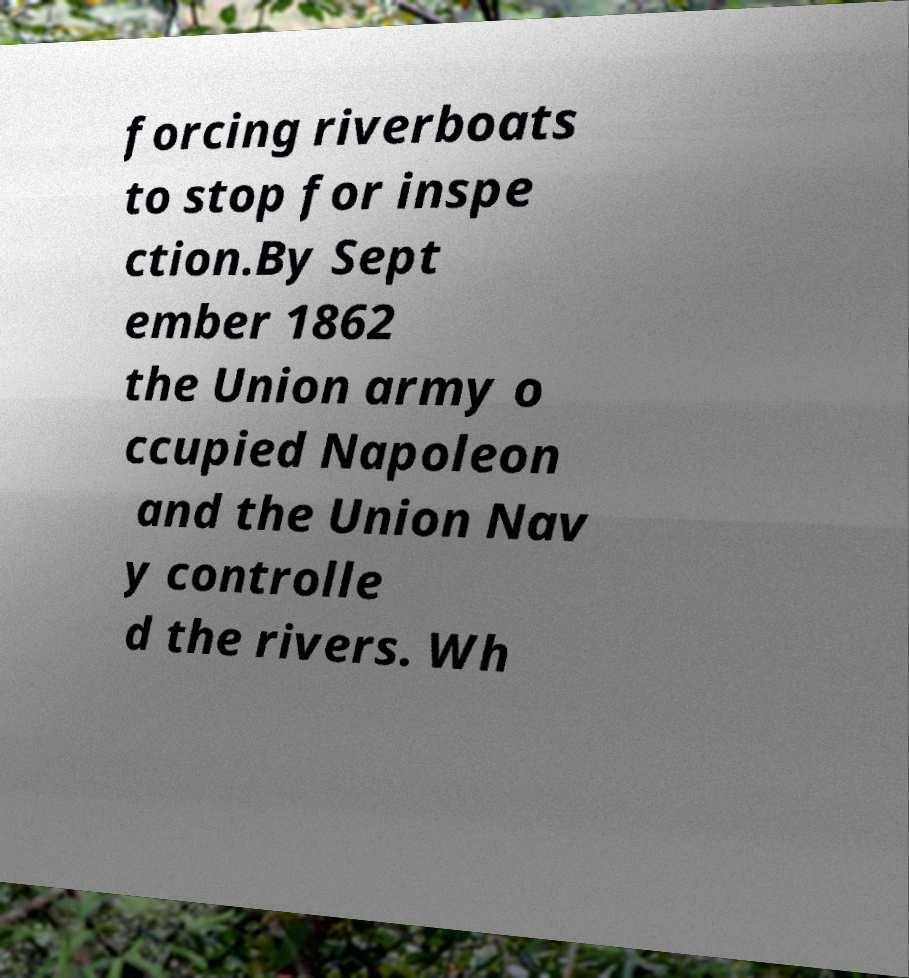Please read and relay the text visible in this image. What does it say? forcing riverboats to stop for inspe ction.By Sept ember 1862 the Union army o ccupied Napoleon and the Union Nav y controlle d the rivers. Wh 